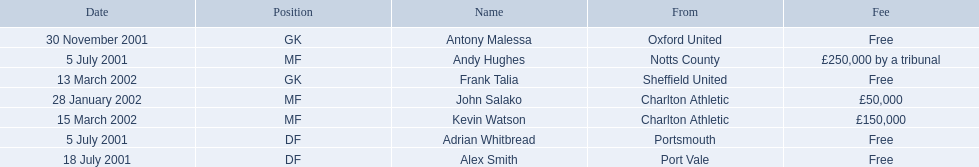What are the names of all the players? Andy Hughes, Adrian Whitbread, Alex Smith, Antony Malessa, John Salako, Frank Talia, Kevin Watson. What fee did andy hughes command? £250,000 by a tribunal. What fee did john salako command? £50,000. Which player had the highest fee, andy hughes or john salako? Andy Hughes. 